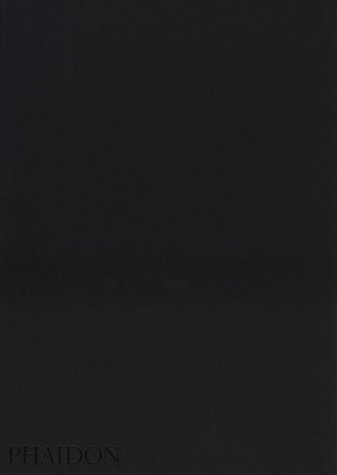What is the genre of this book? The book falls under the genre of 'Christian Books & Bibles,' specifically focusing on the unique aspects of the Mennonite faith and their community lifestyle. 